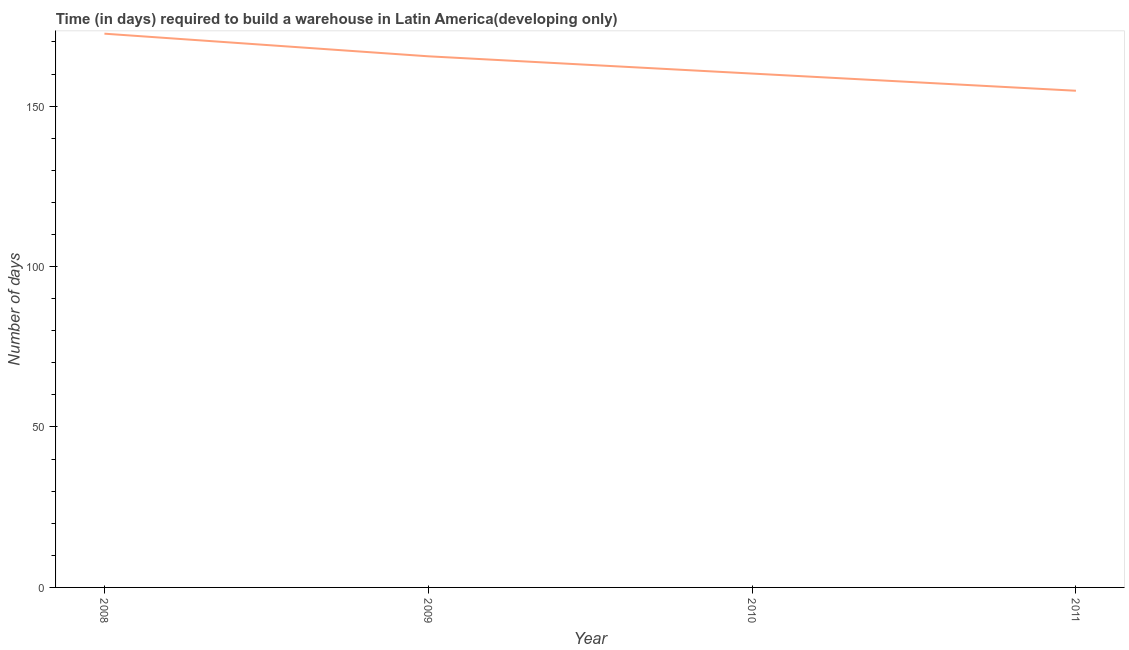What is the time required to build a warehouse in 2010?
Your answer should be compact. 160.14. Across all years, what is the maximum time required to build a warehouse?
Your answer should be very brief. 172.57. Across all years, what is the minimum time required to build a warehouse?
Offer a very short reply. 154.79. In which year was the time required to build a warehouse maximum?
Ensure brevity in your answer.  2008. What is the sum of the time required to build a warehouse?
Make the answer very short. 653.02. What is the difference between the time required to build a warehouse in 2008 and 2009?
Your response must be concise. 7.05. What is the average time required to build a warehouse per year?
Your answer should be compact. 163.26. What is the median time required to build a warehouse?
Your answer should be compact. 162.83. In how many years, is the time required to build a warehouse greater than 130 days?
Your answer should be compact. 4. Do a majority of the years between 2009 and 2011 (inclusive) have time required to build a warehouse greater than 10 days?
Provide a short and direct response. Yes. What is the ratio of the time required to build a warehouse in 2009 to that in 2011?
Your answer should be compact. 1.07. What is the difference between the highest and the second highest time required to build a warehouse?
Your answer should be very brief. 7.05. Is the sum of the time required to build a warehouse in 2008 and 2009 greater than the maximum time required to build a warehouse across all years?
Provide a short and direct response. Yes. What is the difference between the highest and the lowest time required to build a warehouse?
Provide a short and direct response. 17.79. Does the time required to build a warehouse monotonically increase over the years?
Provide a succinct answer. No. How many lines are there?
Ensure brevity in your answer.  1. Are the values on the major ticks of Y-axis written in scientific E-notation?
Make the answer very short. No. Does the graph contain any zero values?
Offer a terse response. No. What is the title of the graph?
Your answer should be very brief. Time (in days) required to build a warehouse in Latin America(developing only). What is the label or title of the X-axis?
Offer a terse response. Year. What is the label or title of the Y-axis?
Provide a short and direct response. Number of days. What is the Number of days in 2008?
Your answer should be compact. 172.57. What is the Number of days of 2009?
Make the answer very short. 165.52. What is the Number of days of 2010?
Make the answer very short. 160.14. What is the Number of days in 2011?
Ensure brevity in your answer.  154.79. What is the difference between the Number of days in 2008 and 2009?
Make the answer very short. 7.05. What is the difference between the Number of days in 2008 and 2010?
Give a very brief answer. 12.43. What is the difference between the Number of days in 2008 and 2011?
Your answer should be compact. 17.79. What is the difference between the Number of days in 2009 and 2010?
Give a very brief answer. 5.38. What is the difference between the Number of days in 2009 and 2011?
Make the answer very short. 10.74. What is the difference between the Number of days in 2010 and 2011?
Offer a very short reply. 5.36. What is the ratio of the Number of days in 2008 to that in 2009?
Your response must be concise. 1.04. What is the ratio of the Number of days in 2008 to that in 2010?
Offer a very short reply. 1.08. What is the ratio of the Number of days in 2008 to that in 2011?
Your response must be concise. 1.11. What is the ratio of the Number of days in 2009 to that in 2010?
Offer a terse response. 1.03. What is the ratio of the Number of days in 2009 to that in 2011?
Make the answer very short. 1.07. What is the ratio of the Number of days in 2010 to that in 2011?
Give a very brief answer. 1.03. 